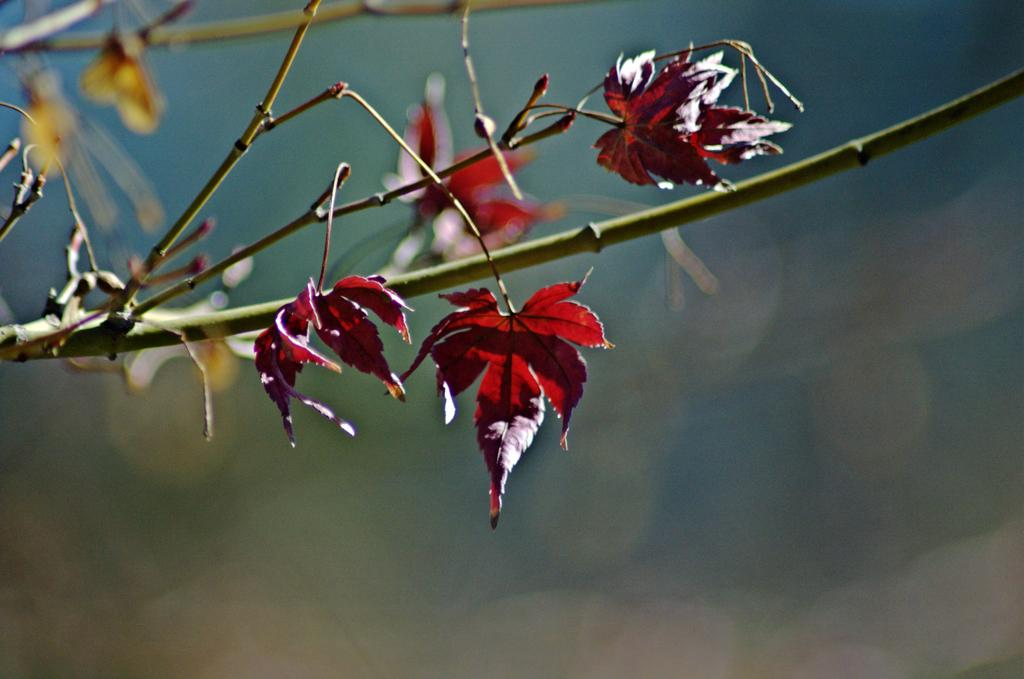What type of vegetation can be seen in the image? There are leaves on the branches of a tree in the image. Can you describe the leaves on the tree? The leaves are on the branches of a tree. What type of meat can be seen hanging from the branches of the tree in the image? There is no meat present in the image; it only features leaves on the branches of a tree. 